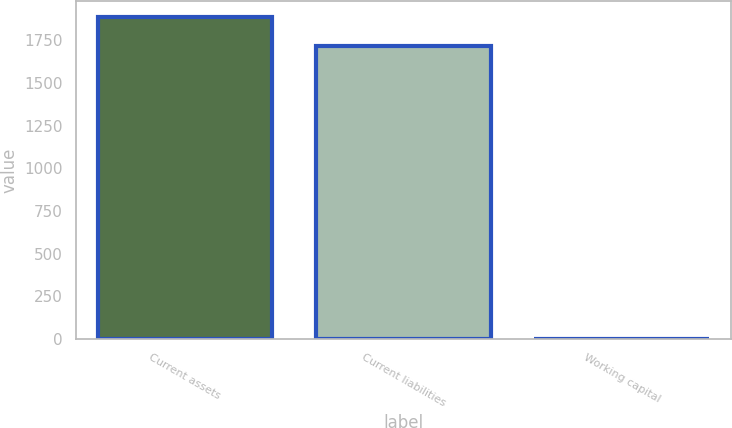Convert chart to OTSL. <chart><loc_0><loc_0><loc_500><loc_500><bar_chart><fcel>Current assets<fcel>Current liabilities<fcel>Working capital<nl><fcel>1886.39<fcel>1714.9<fcel>2<nl></chart> 